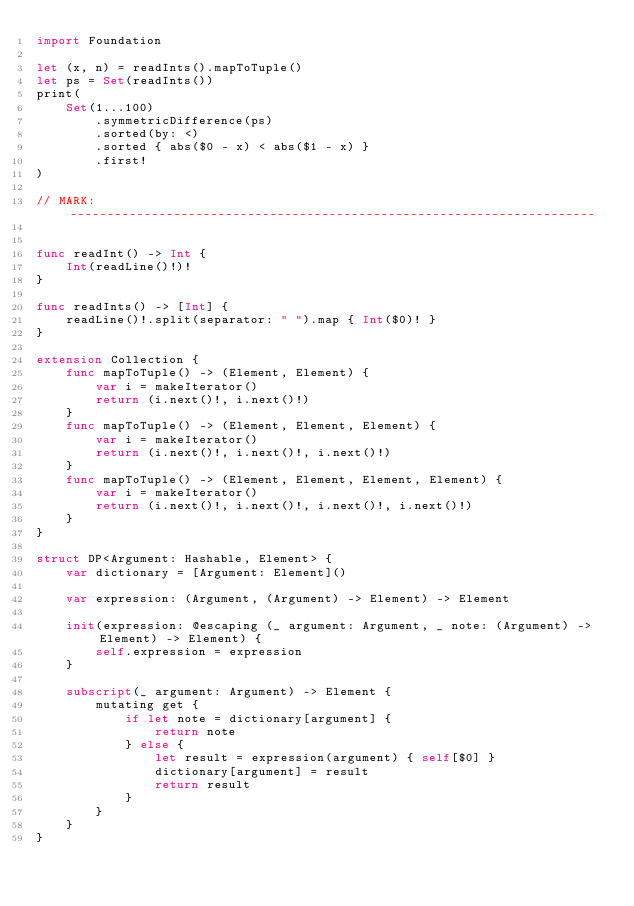<code> <loc_0><loc_0><loc_500><loc_500><_Swift_>import Foundation

let (x, n) = readInts().mapToTuple()
let ps = Set(readInts())
print(
    Set(1...100)
        .symmetricDifference(ps)
        .sorted(by: <)
        .sorted { abs($0 - x) < abs($1 - x) }
        .first!
)

// MARK: -----------------------------------------------------------------------


func readInt() -> Int {
    Int(readLine()!)!
}

func readInts() -> [Int] {
    readLine()!.split(separator: " ").map { Int($0)! }
}

extension Collection {
    func mapToTuple() -> (Element, Element) {
        var i = makeIterator()
        return (i.next()!, i.next()!)
    }
    func mapToTuple() -> (Element, Element, Element) {
        var i = makeIterator()
        return (i.next()!, i.next()!, i.next()!)
    }
    func mapToTuple() -> (Element, Element, Element, Element) {
        var i = makeIterator()
        return (i.next()!, i.next()!, i.next()!, i.next()!)
    }
}

struct DP<Argument: Hashable, Element> {
    var dictionary = [Argument: Element]()
    
    var expression: (Argument, (Argument) -> Element) -> Element
    
    init(expression: @escaping (_ argument: Argument, _ note: (Argument) -> Element) -> Element) {
        self.expression = expression
    }
    
    subscript(_ argument: Argument) -> Element {
        mutating get {
            if let note = dictionary[argument] {
                return note
            } else {
                let result = expression(argument) { self[$0] }
                dictionary[argument] = result
                return result
            }
        }
    }
}
</code> 